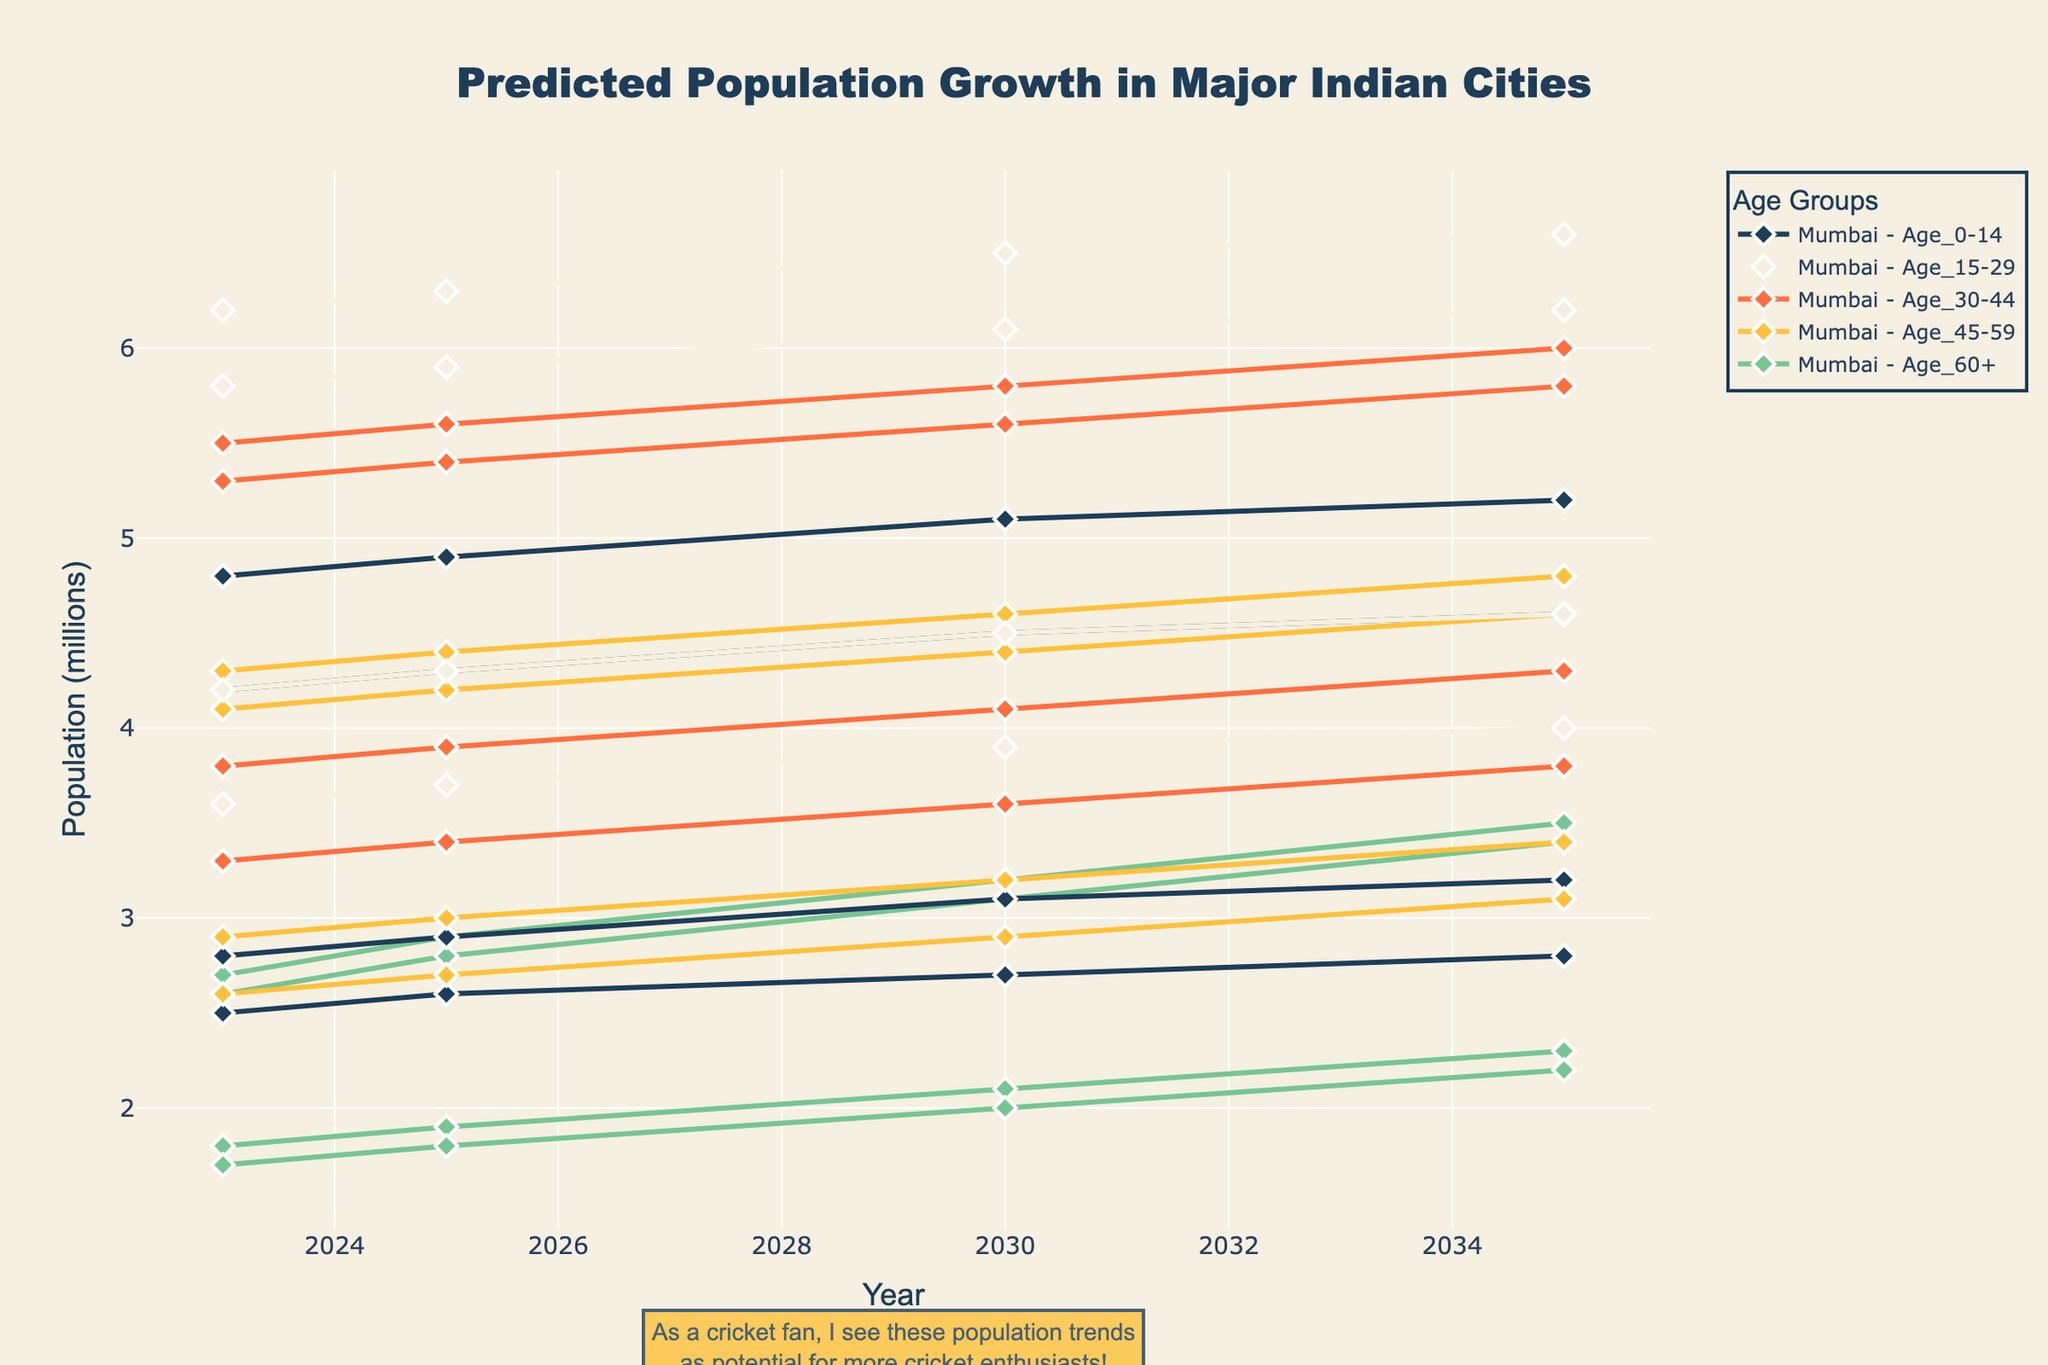What is the title of the figure? The title is located at the top of the figure, prominently displayed. It reads "Predicted Population Growth in Major Indian Cities".
Answer: Predicted Population Growth in Major Indian Cities Which city is predicted to have the highest population in the age group 0-14 in 2035? In the figure, locate the line corresponding to the age group 0-14 for each city and refer to their values in 2035. Compare these values to determine that Delhi has the highest population at 5.2 million.
Answer: Delhi How does the population of the age group 60+ in Chennai change from 2023 to 2035? Identify the line for Chennai's age group 60+ and observe the population values from 2023 to 2035. It increases from 1.7 million in 2023 to 2.2 million in 2035. Calculate the difference: 2.2 million - 1.7 million = 0.5 million.
Answer: It increases by 0.5 million Which city sees the largest growth in the age group 15-29 from 2023 to 2035? For each city, compare the 2023 and 2035 values of the age group 15-29. Calculate the growth by subtracting the 2023 value from the 2035 value. Delhi has the largest growth with an increase from 6.2 million to 6.6 million, growing by 0.4 million.
Answer: Delhi How does the predicted population trend of Mumbai for the age group 30-44 compare to that of Bangalore from 2023 to 2035? Compare the lines of Mumbai and Bangalore for the age group 30-44 across the years from 2023 to 2035. Mumbai's population grows from 5.3 million to 5.8 million, while Bangalore's grows from 3.8 million to 4.3 million. Both trends are upward, but Mumbai starts higher and grows slightly less.
Answer: Both cities have an upward trend, with Mumbai consistently having a higher population Which city has the lowest predicted population in the age group 45-59 in 2030? Check the 2030 values for the age group 45-59 in each city and find the lowest. Chennai has the lowest predicted population at 2.9 million.
Answer: Chennai From 2023 to 2035, which age group in Delhi shows the largest increase in population? For Delhi, calculate the population increase for each age group from 2023 to 2035. Age 60+ shows the largest increase, from 2.7 million to 3.5 million, an increase of 0.8 million.
Answer: Age 60+ Are any age groups in any city predicted to have a decline in population between 2023 and 2035? Examine the trend lines for all age groups in each city from 2023 to 2035. All lines for all age groups in every city show an upward trend; hence, there is no decline.
Answer: No What year does Bangalore's age group 30-44 surpass 4 million? Follow the trend line for Bangalore's age group 30-44 and identify the year it first surpasses 4 million. It does so in 2030.
Answer: 2030 How does the predicted population of the age group 15-29 in 2025 compare between Mumbai and Chennai? Compare the 2025 values of the age group 15-29 for Mumbai and Chennai. Mumbai has 5.9 million, while Chennai has 3.7 million.
Answer: Mumbai has a higher population than Chennai 